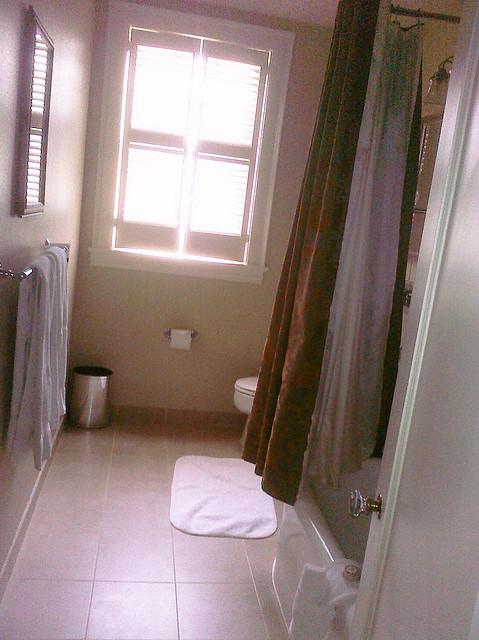Is there a window?
Quick response, please. Yes. Is the shower curtain in the appropriate spot?
Be succinct. Yes. If someone stepped out of the shower right now is the floor likely to get wet?
Short answer required. No. 